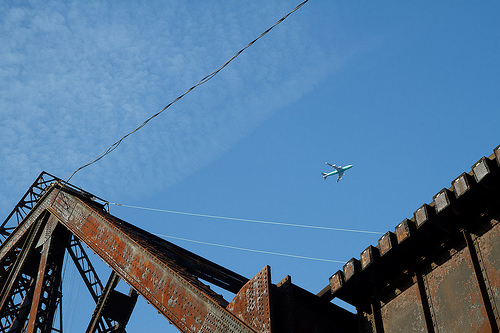Please provide a short description for this region: [0.13, 0.66, 0.21, 0.75]. A metallic ladder firmly attached to a complex machine. 